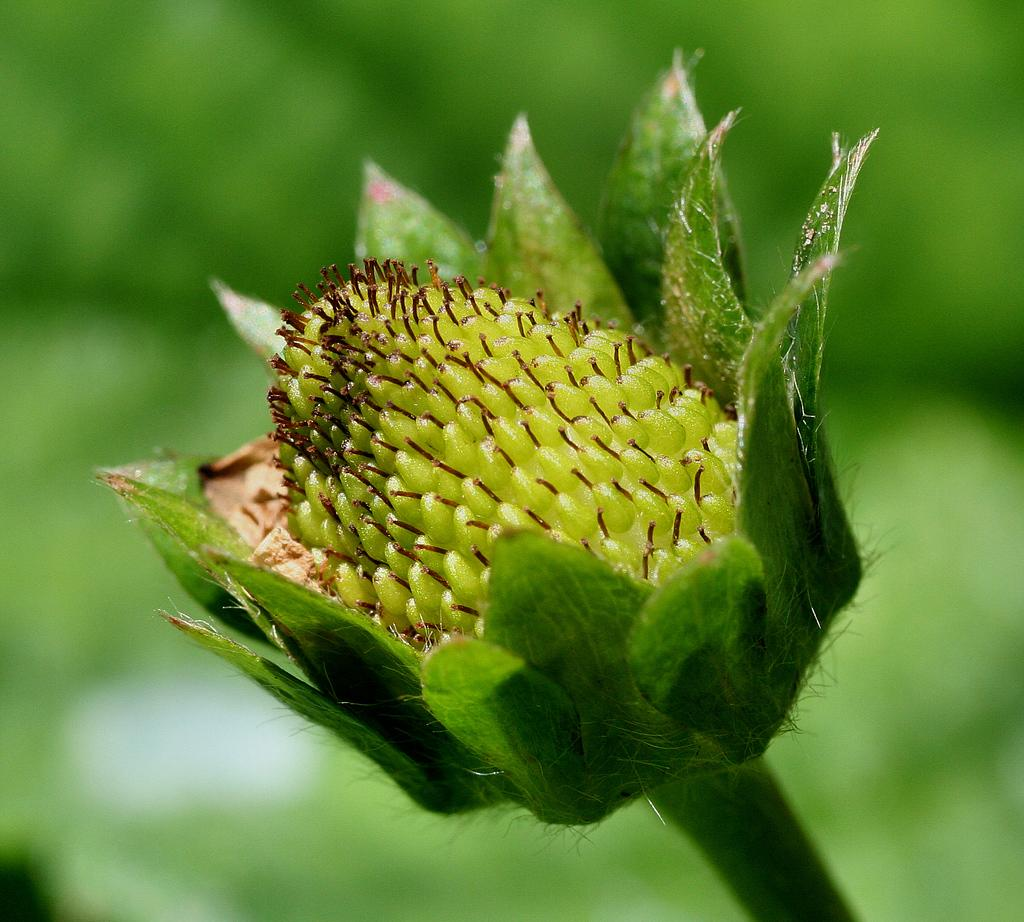What is the main subject of the image? The main subject of the image is a plant. What feature of the plant is highlighted in the image? The plant has a flower. Can you describe the background of the image? The background of the image is blurred. What type of legal advice can be obtained from the plant in the image? There is no lawyer or legal advice present in the image; it features a plant with a flower. What color is the chalk used to draw on the plant in the image? There is no chalk or drawing present on the plant in the image. 